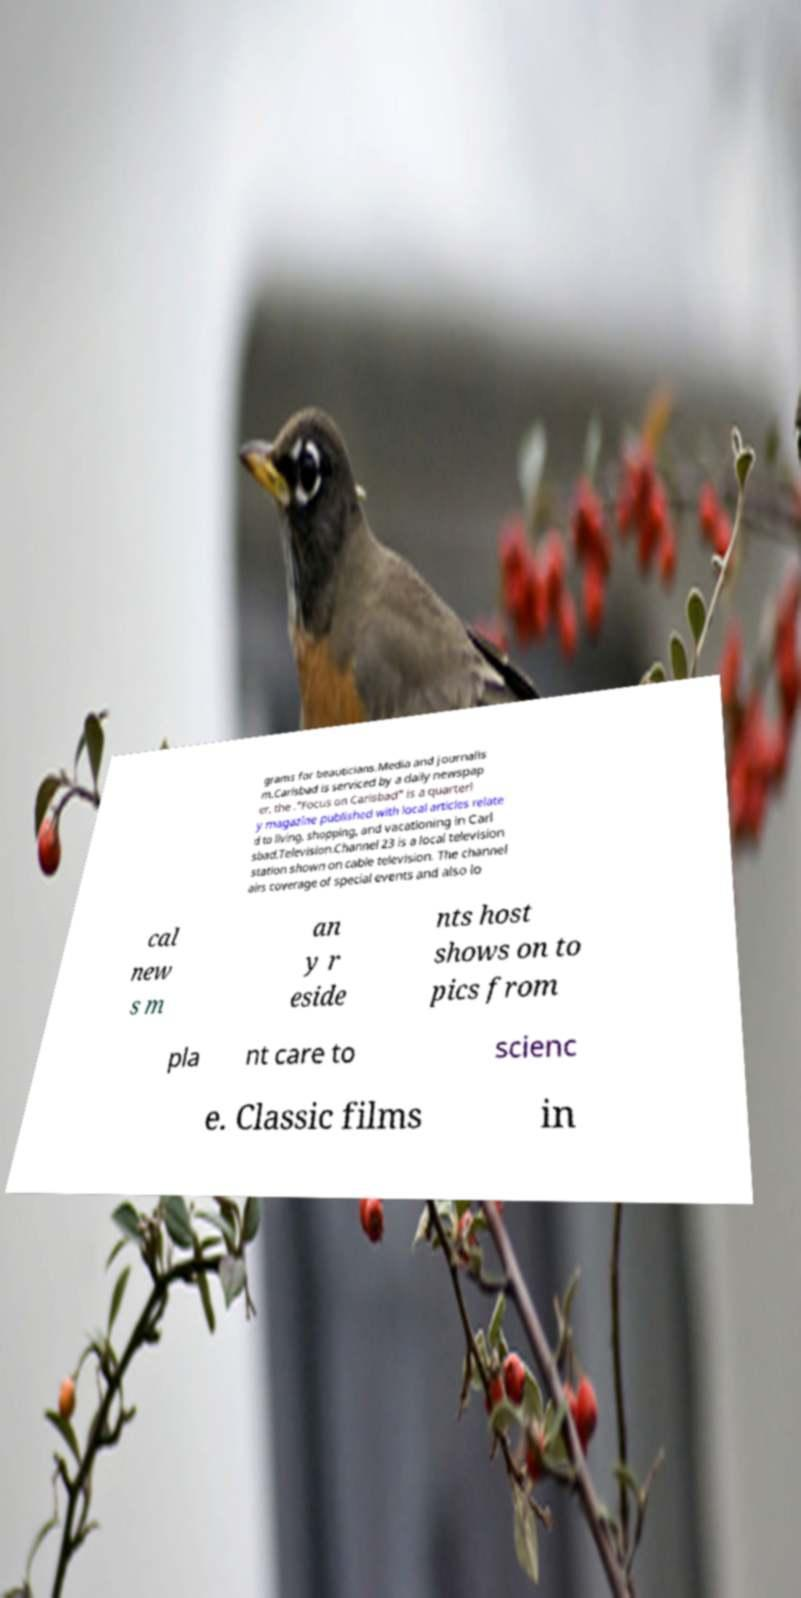For documentation purposes, I need the text within this image transcribed. Could you provide that? grams for beauticians.Media and journalis m.Carlsbad is serviced by a daily newspap er, the ."Focus on Carlsbad" is a quarterl y magazine published with local articles relate d to living, shopping, and vacationing in Carl sbad.Television.Channel 23 is a local television station shown on cable television. The channel airs coverage of special events and also lo cal new s m an y r eside nts host shows on to pics from pla nt care to scienc e. Classic films in 